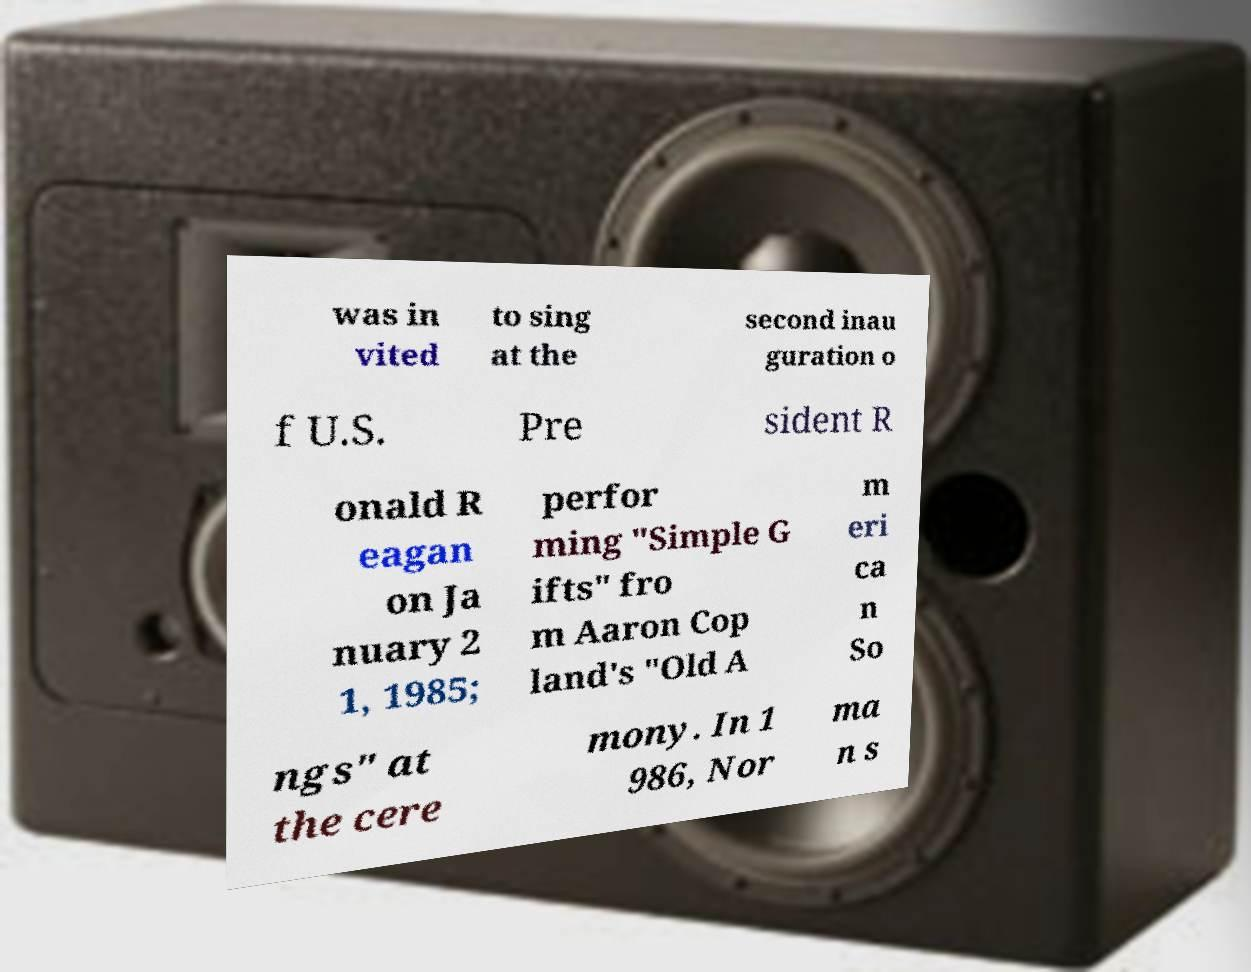Can you accurately transcribe the text from the provided image for me? was in vited to sing at the second inau guration o f U.S. Pre sident R onald R eagan on Ja nuary 2 1, 1985; perfor ming "Simple G ifts" fro m Aaron Cop land's "Old A m eri ca n So ngs" at the cere mony. In 1 986, Nor ma n s 